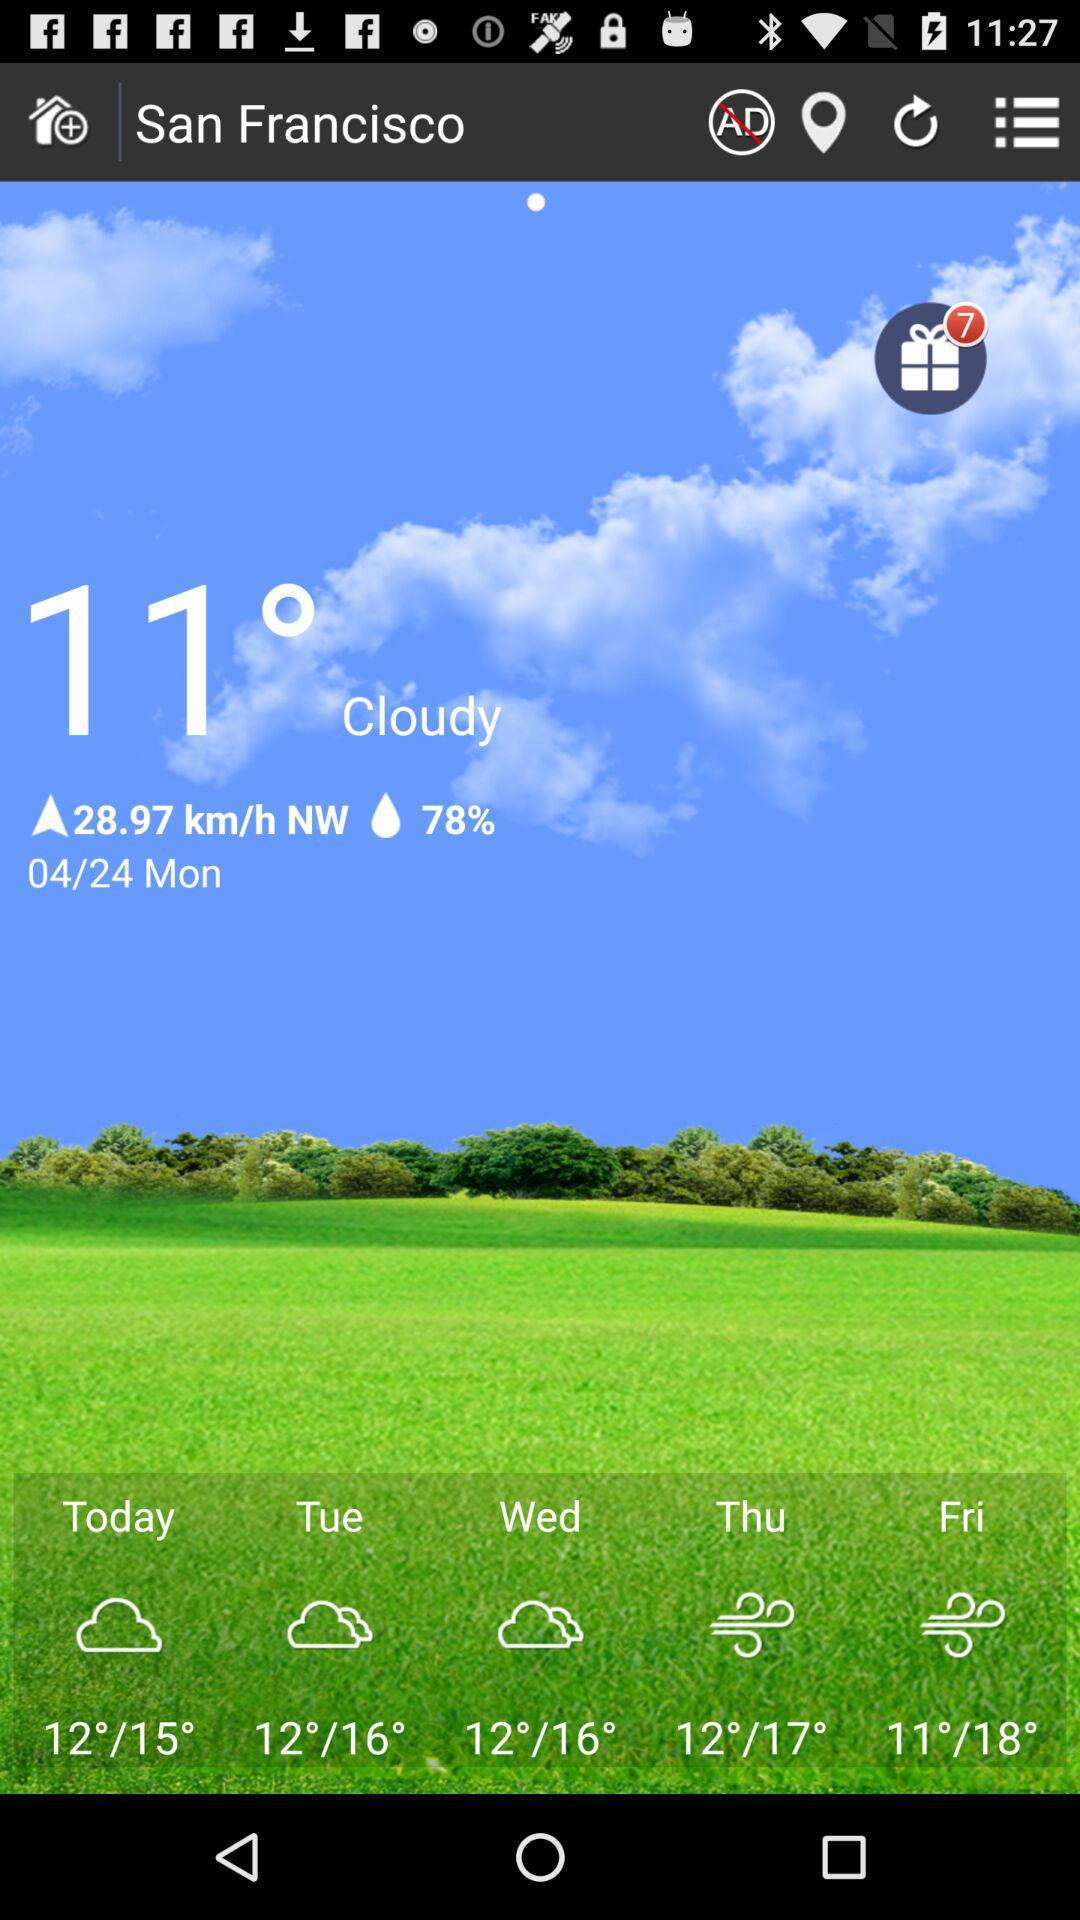What is the percentage of humidity? The percentage of humidity is 78. 